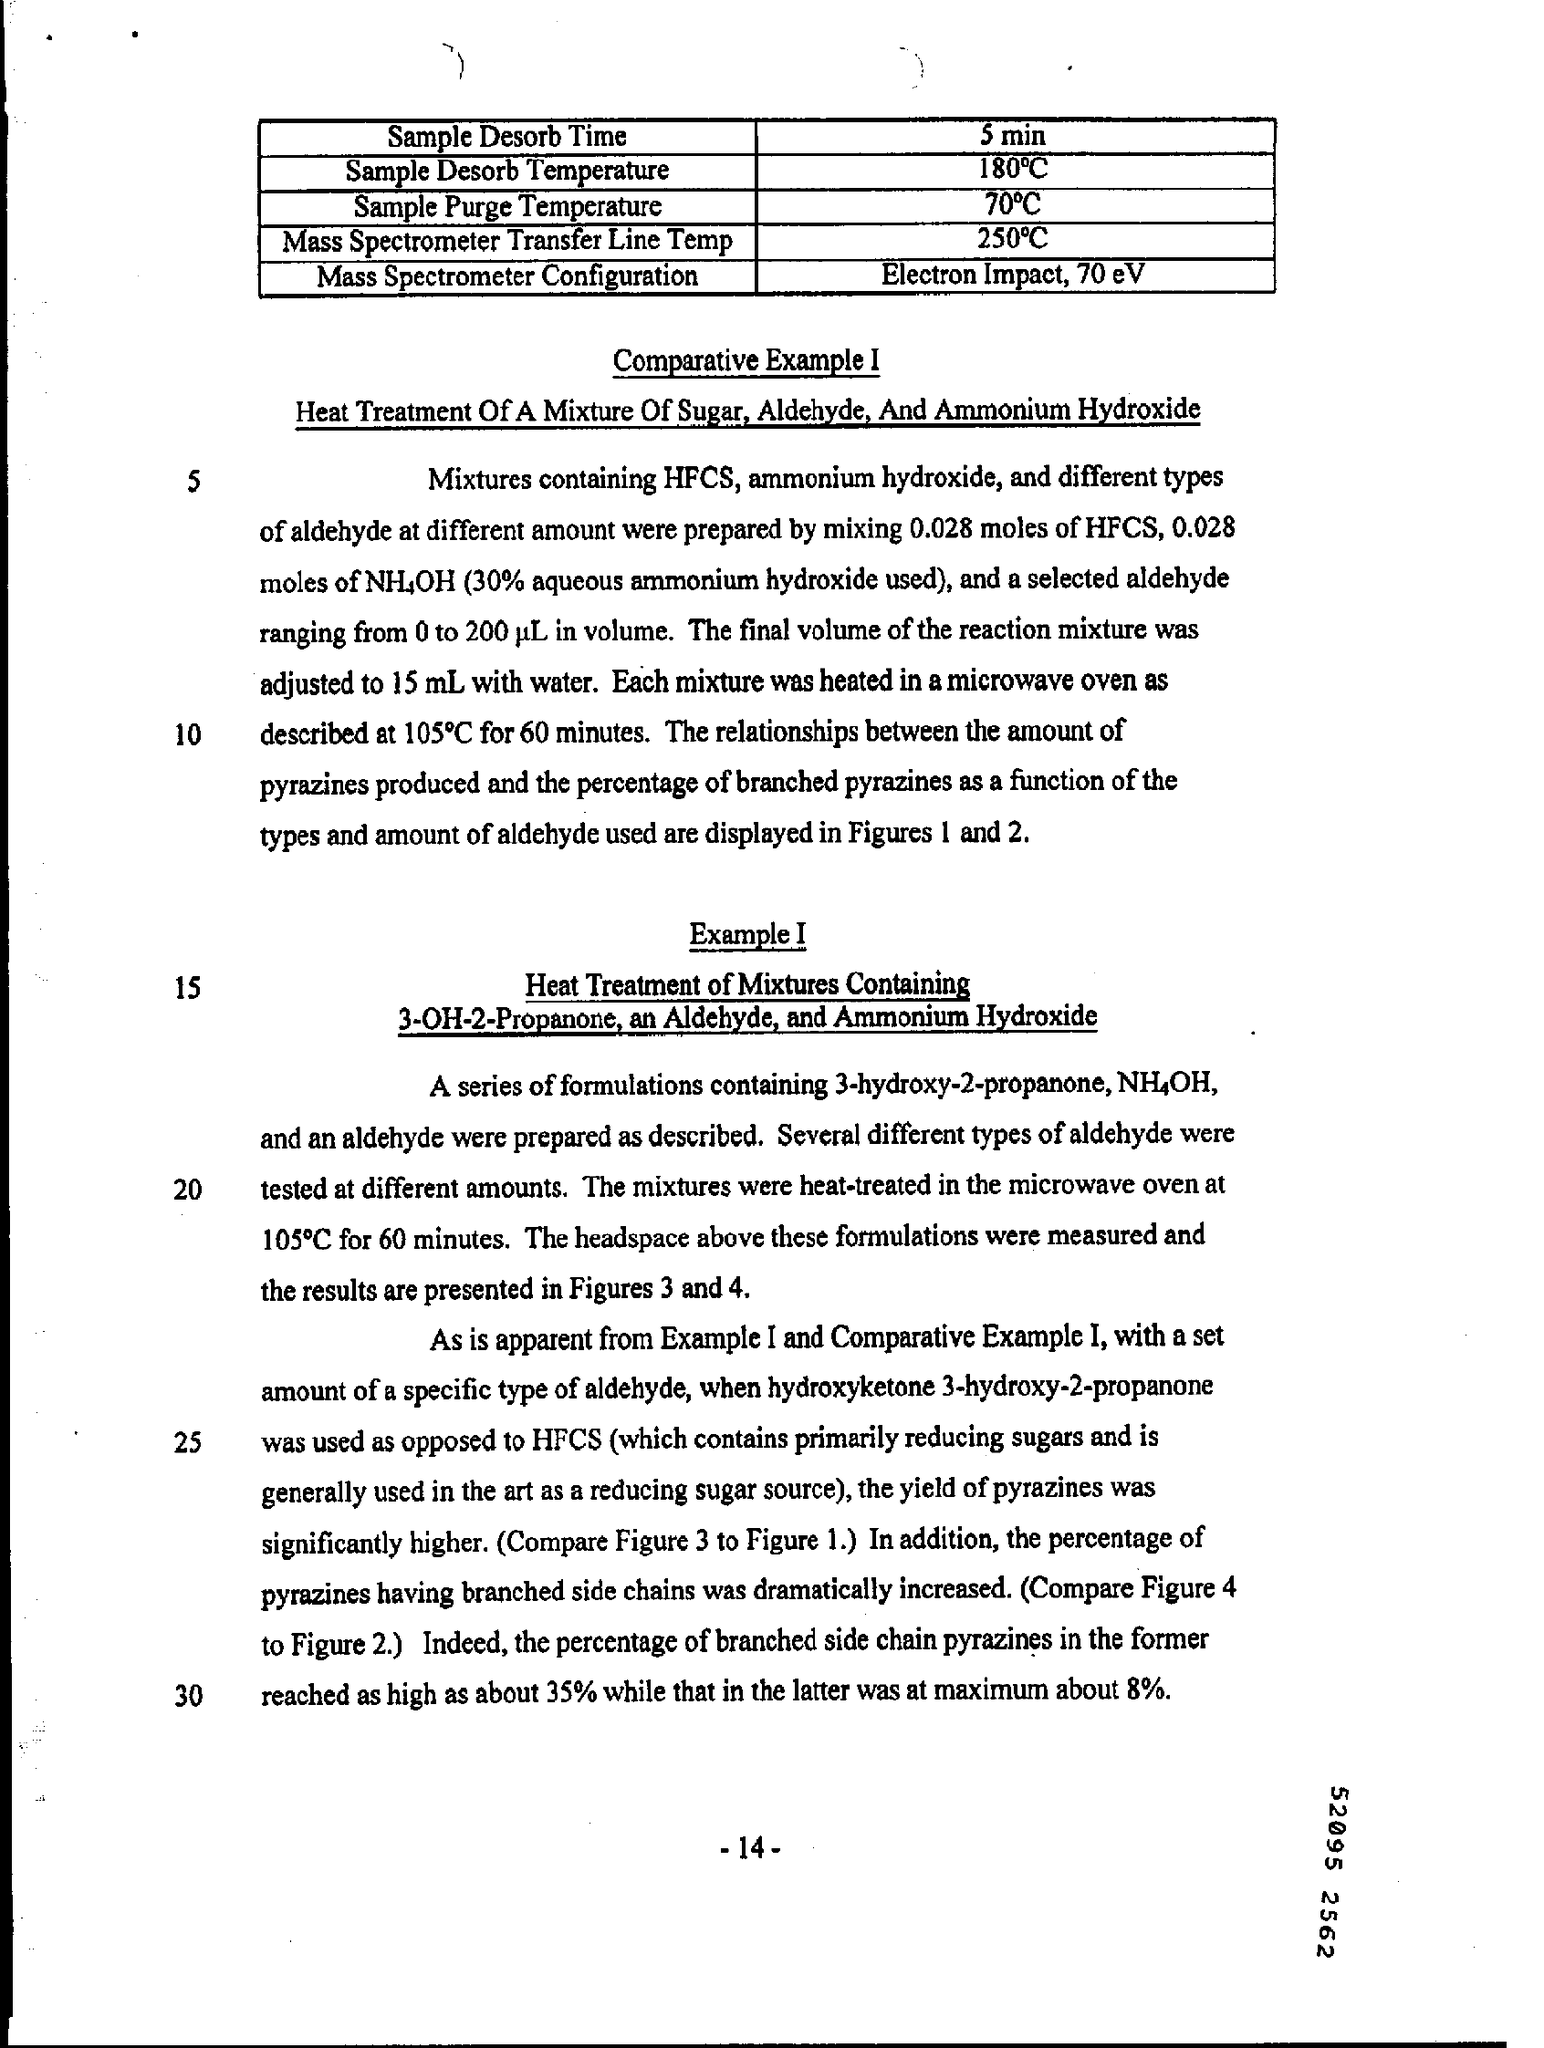What is the Sample Desorb Time given in the document?
Provide a short and direct response. 5 min. What is the Mass Spectrometer Configuration mentioned in the document?
Your response must be concise. Electron impact, 70 ev. What is the page no mentioned in this document?
Your response must be concise. -14-. 